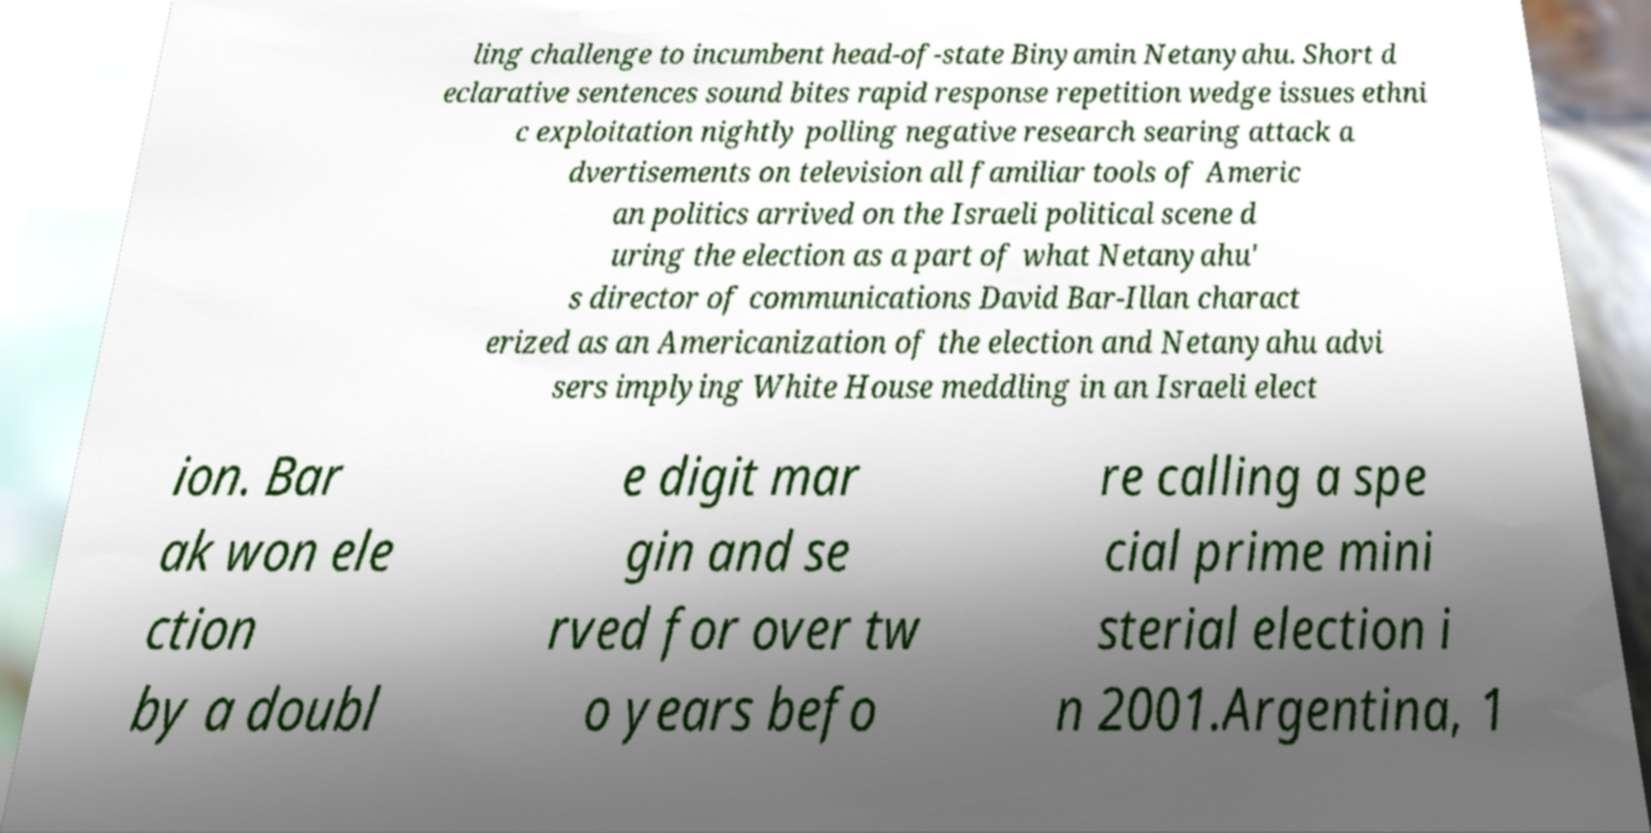Could you assist in decoding the text presented in this image and type it out clearly? ling challenge to incumbent head-of-state Binyamin Netanyahu. Short d eclarative sentences sound bites rapid response repetition wedge issues ethni c exploitation nightly polling negative research searing attack a dvertisements on television all familiar tools of Americ an politics arrived on the Israeli political scene d uring the election as a part of what Netanyahu' s director of communications David Bar-Illan charact erized as an Americanization of the election and Netanyahu advi sers implying White House meddling in an Israeli elect ion. Bar ak won ele ction by a doubl e digit mar gin and se rved for over tw o years befo re calling a spe cial prime mini sterial election i n 2001.Argentina, 1 